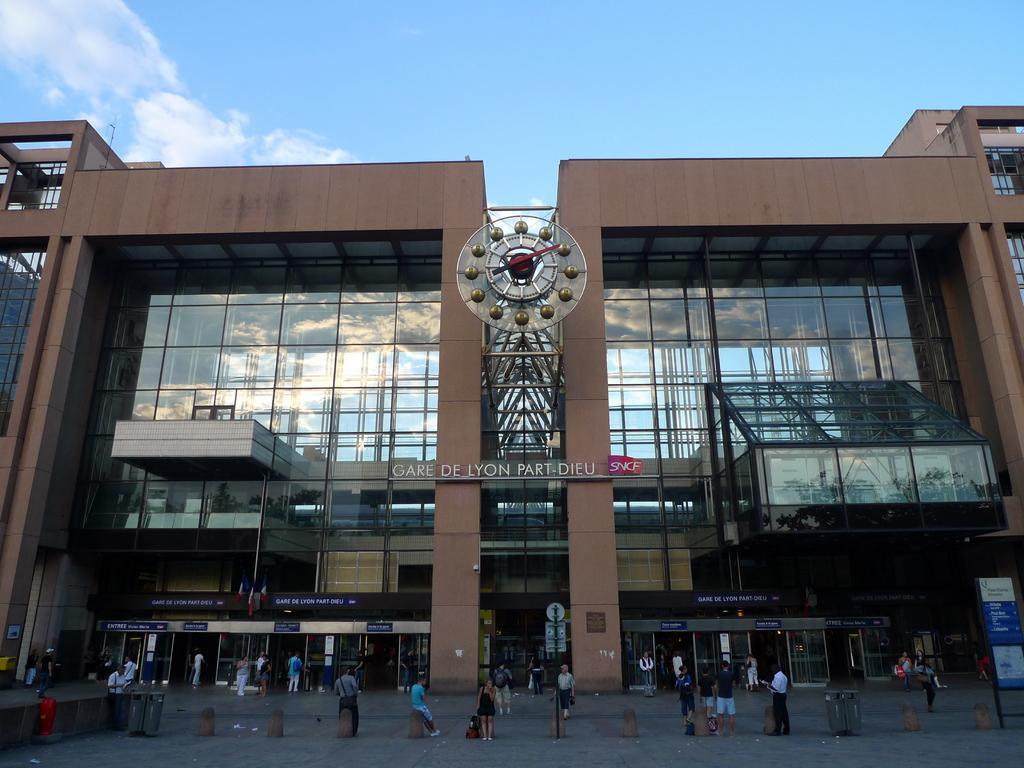Could you give a brief overview of what you see in this image? This is the picture of a building. In this image there is a building and there is a text on the building. In the foreground there are group of people standing and there are boards on the poles. At the top there is sky and there are clouds. At the bottom there is a road. 